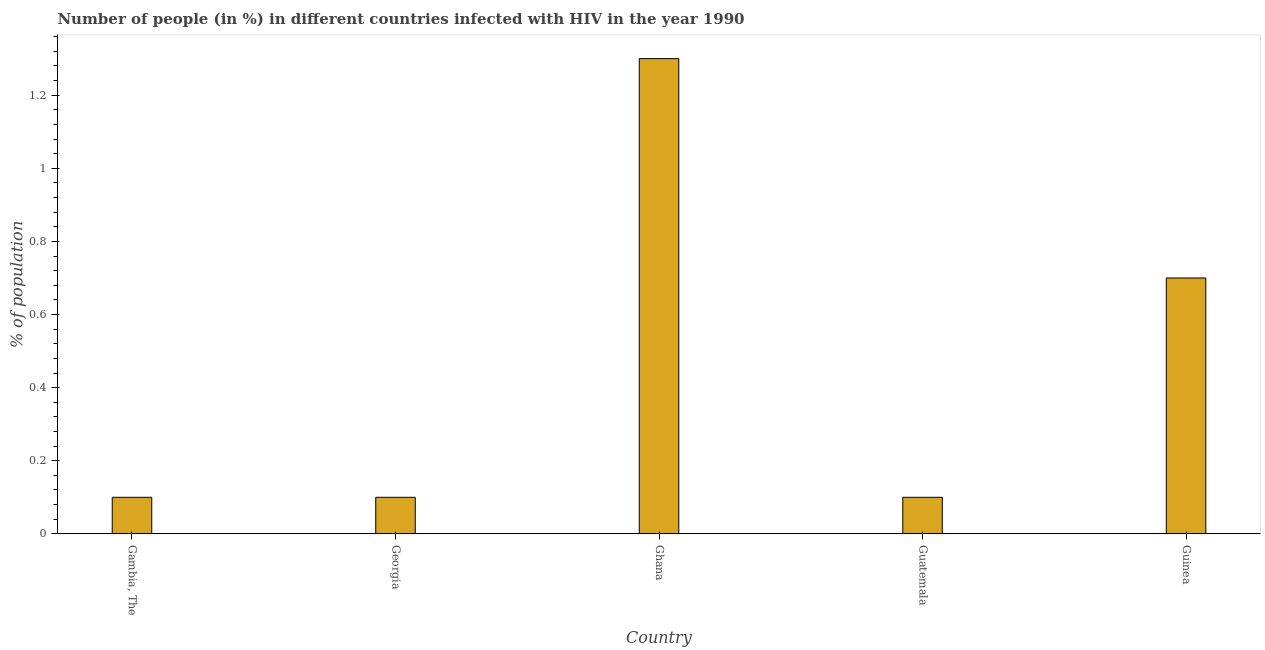Does the graph contain grids?
Your response must be concise. No. What is the title of the graph?
Your answer should be compact. Number of people (in %) in different countries infected with HIV in the year 1990. What is the label or title of the X-axis?
Make the answer very short. Country. What is the label or title of the Y-axis?
Make the answer very short. % of population. What is the number of people infected with hiv in Guinea?
Your response must be concise. 0.7. Across all countries, what is the minimum number of people infected with hiv?
Provide a short and direct response. 0.1. In which country was the number of people infected with hiv minimum?
Offer a very short reply. Gambia, The. What is the sum of the number of people infected with hiv?
Offer a very short reply. 2.3. What is the difference between the number of people infected with hiv in Georgia and Ghana?
Make the answer very short. -1.2. What is the average number of people infected with hiv per country?
Offer a very short reply. 0.46. Is the difference between the number of people infected with hiv in Guatemala and Guinea greater than the difference between any two countries?
Keep it short and to the point. No. Is the sum of the number of people infected with hiv in Gambia, The and Guatemala greater than the maximum number of people infected with hiv across all countries?
Your answer should be compact. No. What is the difference between the highest and the lowest number of people infected with hiv?
Your answer should be compact. 1.2. In how many countries, is the number of people infected with hiv greater than the average number of people infected with hiv taken over all countries?
Make the answer very short. 2. How many bars are there?
Provide a succinct answer. 5. How many countries are there in the graph?
Make the answer very short. 5. What is the % of population of Gambia, The?
Make the answer very short. 0.1. What is the % of population in Ghana?
Your answer should be compact. 1.3. What is the % of population in Guatemala?
Offer a very short reply. 0.1. What is the % of population of Guinea?
Offer a terse response. 0.7. What is the difference between the % of population in Gambia, The and Georgia?
Your answer should be very brief. 0. What is the difference between the % of population in Gambia, The and Guinea?
Your answer should be very brief. -0.6. What is the difference between the % of population in Georgia and Guatemala?
Your answer should be very brief. 0. What is the difference between the % of population in Georgia and Guinea?
Provide a short and direct response. -0.6. What is the difference between the % of population in Ghana and Guatemala?
Ensure brevity in your answer.  1.2. What is the difference between the % of population in Guatemala and Guinea?
Offer a very short reply. -0.6. What is the ratio of the % of population in Gambia, The to that in Ghana?
Provide a succinct answer. 0.08. What is the ratio of the % of population in Gambia, The to that in Guinea?
Give a very brief answer. 0.14. What is the ratio of the % of population in Georgia to that in Ghana?
Ensure brevity in your answer.  0.08. What is the ratio of the % of population in Georgia to that in Guinea?
Your answer should be very brief. 0.14. What is the ratio of the % of population in Ghana to that in Guinea?
Your answer should be very brief. 1.86. What is the ratio of the % of population in Guatemala to that in Guinea?
Your response must be concise. 0.14. 